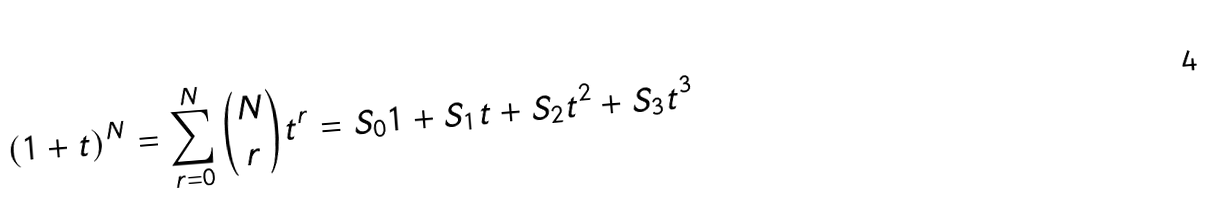Convert formula to latex. <formula><loc_0><loc_0><loc_500><loc_500>( 1 + t ) ^ { N } = \sum _ { r = 0 } ^ { N } \binom { N } { r } t ^ { r } = S _ { 0 } 1 + S _ { 1 } t + S _ { 2 } t ^ { 2 } + S _ { 3 } t ^ { 3 }</formula> 